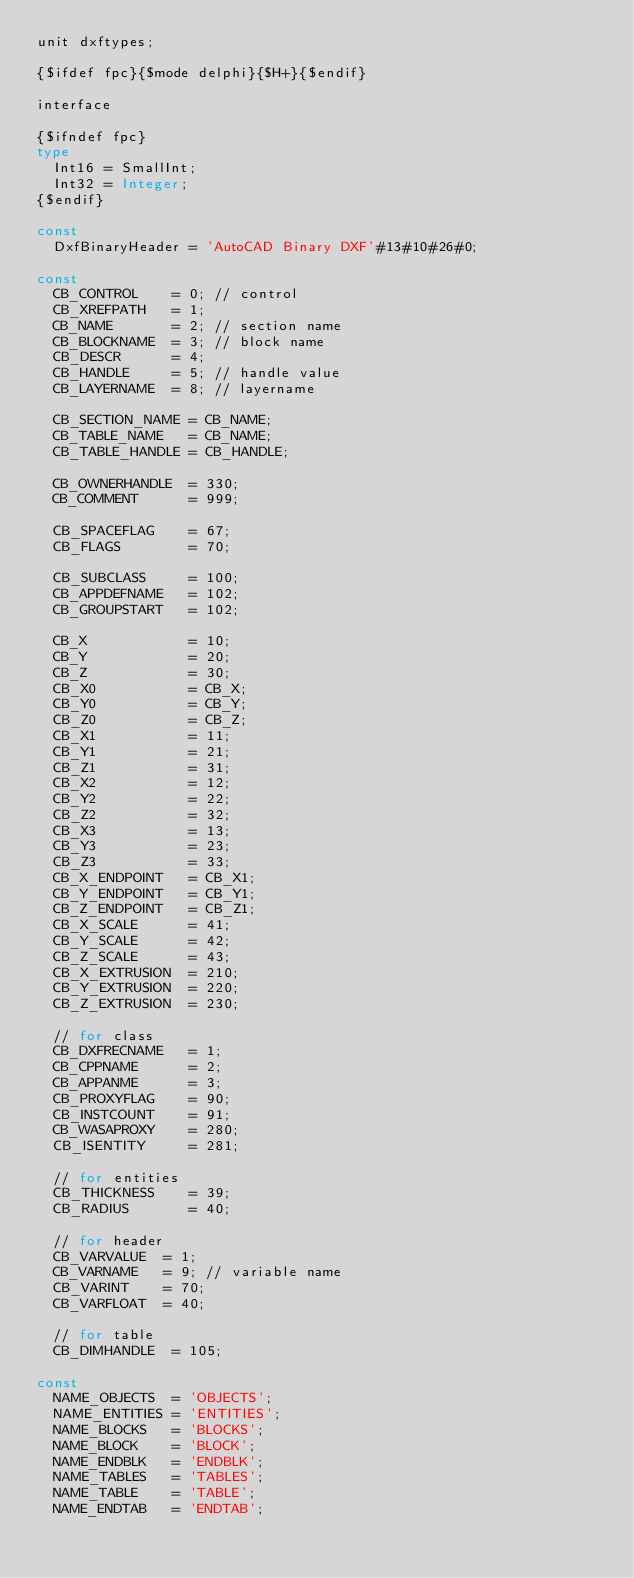Convert code to text. <code><loc_0><loc_0><loc_500><loc_500><_Pascal_>unit dxftypes;

{$ifdef fpc}{$mode delphi}{$H+}{$endif}

interface

{$ifndef fpc}
type
  Int16 = SmallInt;
  Int32 = Integer;
{$endif}

const
  DxfBinaryHeader = 'AutoCAD Binary DXF'#13#10#26#0;

const
  CB_CONTROL    = 0; // control
  CB_XREFPATH   = 1;
  CB_NAME       = 2; // section name
  CB_BLOCKNAME  = 3; // block name
  CB_DESCR      = 4;
  CB_HANDLE     = 5; // handle value
  CB_LAYERNAME  = 8; // layername

  CB_SECTION_NAME = CB_NAME;
  CB_TABLE_NAME   = CB_NAME;
  CB_TABLE_HANDLE = CB_HANDLE;

  CB_OWNERHANDLE  = 330;
  CB_COMMENT      = 999;

  CB_SPACEFLAG    = 67;
  CB_FLAGS        = 70;

  CB_SUBCLASS     = 100;
  CB_APPDEFNAME   = 102;
  CB_GROUPSTART   = 102;

  CB_X            = 10;
  CB_Y            = 20;
  CB_Z            = 30;
  CB_X0           = CB_X;
  CB_Y0           = CB_Y;
  CB_Z0           = CB_Z;
  CB_X1           = 11;
  CB_Y1           = 21;
  CB_Z1           = 31;
  CB_X2           = 12;
  CB_Y2           = 22;
  CB_Z2           = 32;
  CB_X3           = 13;
  CB_Y3           = 23;
  CB_Z3           = 33;
  CB_X_ENDPOINT   = CB_X1;
  CB_Y_ENDPOINT   = CB_Y1;
  CB_Z_ENDPOINT   = CB_Z1;
  CB_X_SCALE      = 41;
  CB_Y_SCALE      = 42;
  CB_Z_SCALE      = 43;
  CB_X_EXTRUSION  = 210;
  CB_Y_EXTRUSION  = 220;
  CB_Z_EXTRUSION  = 230;

  // for class
  CB_DXFRECNAME   = 1;
  CB_CPPNAME      = 2;
  CB_APPANME      = 3;
  CB_PROXYFLAG    = 90;
  CB_INSTCOUNT    = 91;
  CB_WASAPROXY    = 280;
  CB_ISENTITY     = 281;

  // for entities
  CB_THICKNESS    = 39;
  CB_RADIUS       = 40;

  // for header
  CB_VARVALUE  = 1;
  CB_VARNAME   = 9; // variable name
  CB_VARINT    = 70;
  CB_VARFLOAT  = 40;

  // for table
  CB_DIMHANDLE  = 105;

const
  NAME_OBJECTS  = 'OBJECTS';
  NAME_ENTITIES = 'ENTITIES';
  NAME_BLOCKS   = 'BLOCKS';
  NAME_BLOCK    = 'BLOCK';
  NAME_ENDBLK   = 'ENDBLK';
  NAME_TABLES   = 'TABLES';
  NAME_TABLE    = 'TABLE';
  NAME_ENDTAB   = 'ENDTAB';</code> 